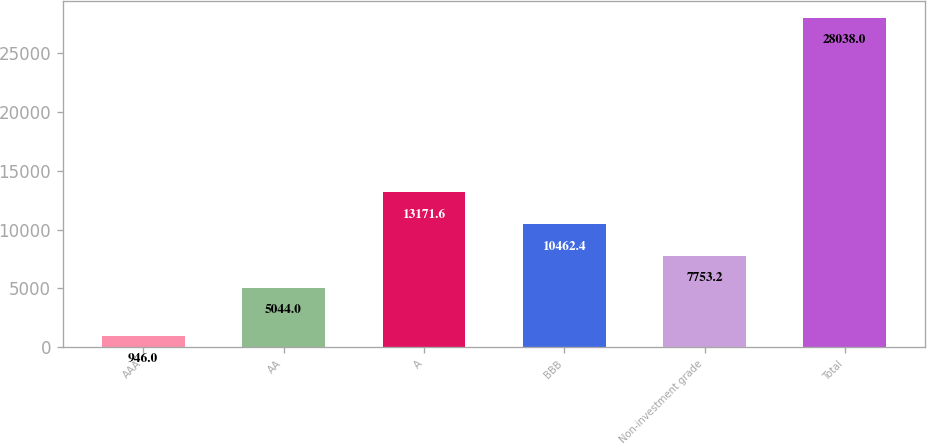Convert chart. <chart><loc_0><loc_0><loc_500><loc_500><bar_chart><fcel>AAA<fcel>AA<fcel>A<fcel>BBB<fcel>Non-investment grade<fcel>Total<nl><fcel>946<fcel>5044<fcel>13171.6<fcel>10462.4<fcel>7753.2<fcel>28038<nl></chart> 